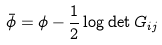Convert formula to latex. <formula><loc_0><loc_0><loc_500><loc_500>\bar { \phi } = \phi - \frac { 1 } { 2 } \log \det G _ { i j }</formula> 